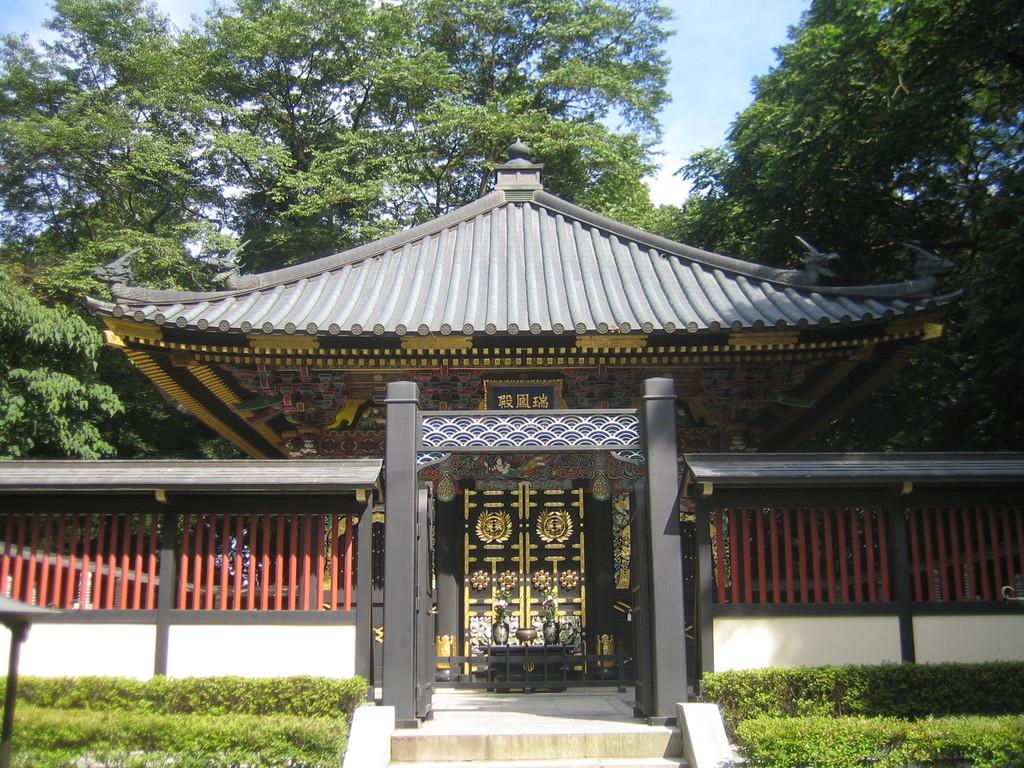What type of building is in the image? There is a hut-shaped building in the image. What is located near the building's door? There is a table outside the building's door. What is on the table? There is a vase on the table. What is on the ground near the building? There are plants on the ground. What can be seen in the background of the image? There are trees visible in the background. How many bedrooms are in the hut-shaped building in the image? The image does not provide information about the number of bedrooms in the building, as it only shows the exterior of the hut. 